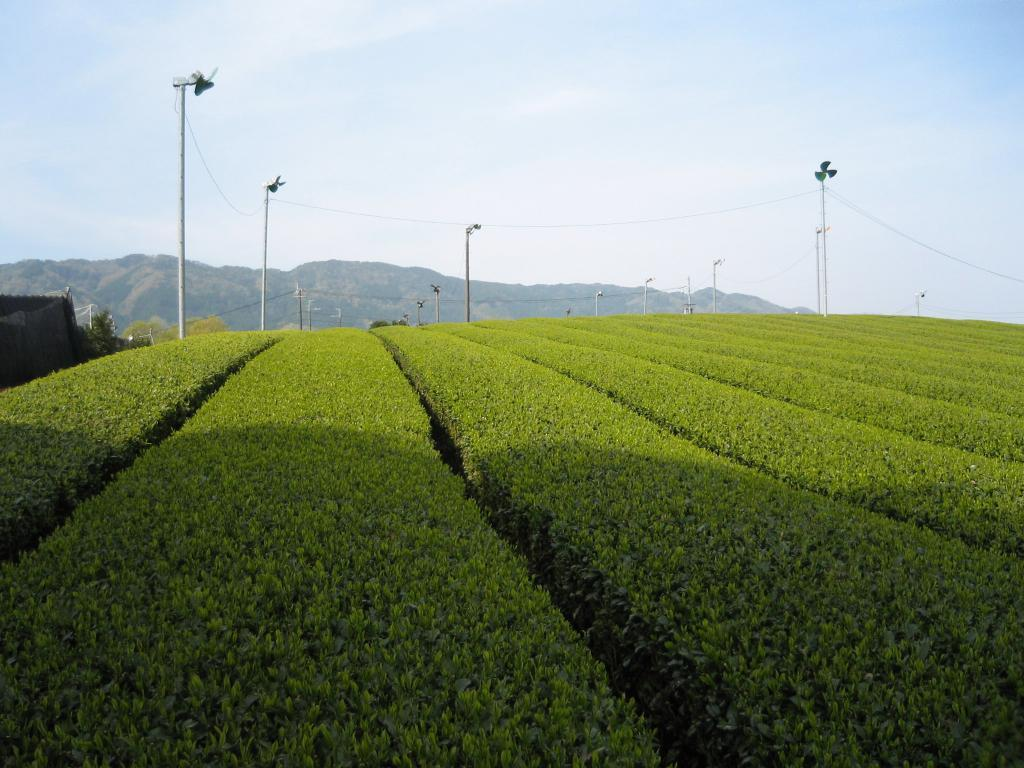What type of living organisms can be seen in the image? Plants can be seen in the image. What objects are present in the image to provide air circulation? There are fans in the image. What can be seen in the background of the image? Trees, mountains, and the sky are visible in the background of the image. How many jellyfish can be seen swimming in the image? There are no jellyfish present in the image. What type of air is being used to power the fans in the image? The image does not specify the type of air being used to power the fans. 